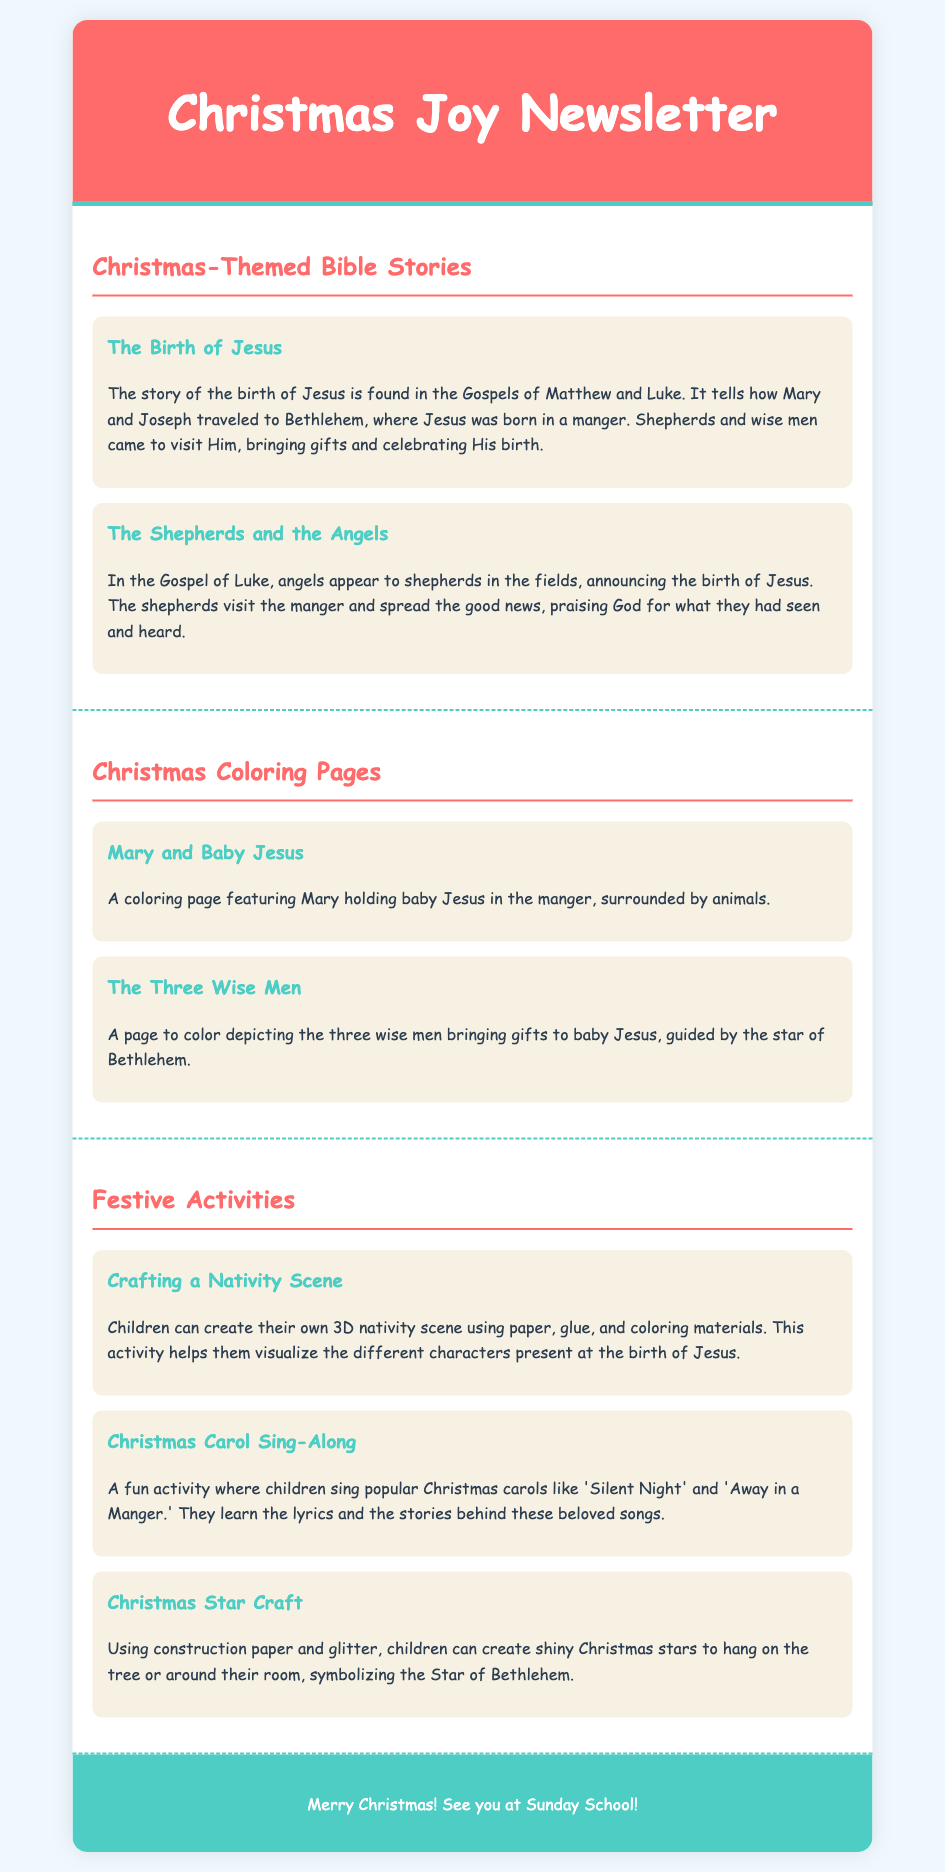what are the titles of the Bible stories? The titles of the Bible stories are "The Birth of Jesus" and "The Shepherds and the Angels."
Answer: The Birth of Jesus, The Shepherds and the Angels how many Christmas coloring pages are there? The document mentions two Christmas coloring pages.
Answer: 2 what activity involves singing? The activity that involves singing is the "Christmas Carol Sing-Along."
Answer: Christmas Carol Sing-Along what can children create using construction paper and glitter? Children can create shiny Christmas stars using construction paper and glitter.
Answer: Christmas stars what is the theme of the newsletter? The theme of the newsletter is "Christmas Joy."
Answer: Christmas Joy 